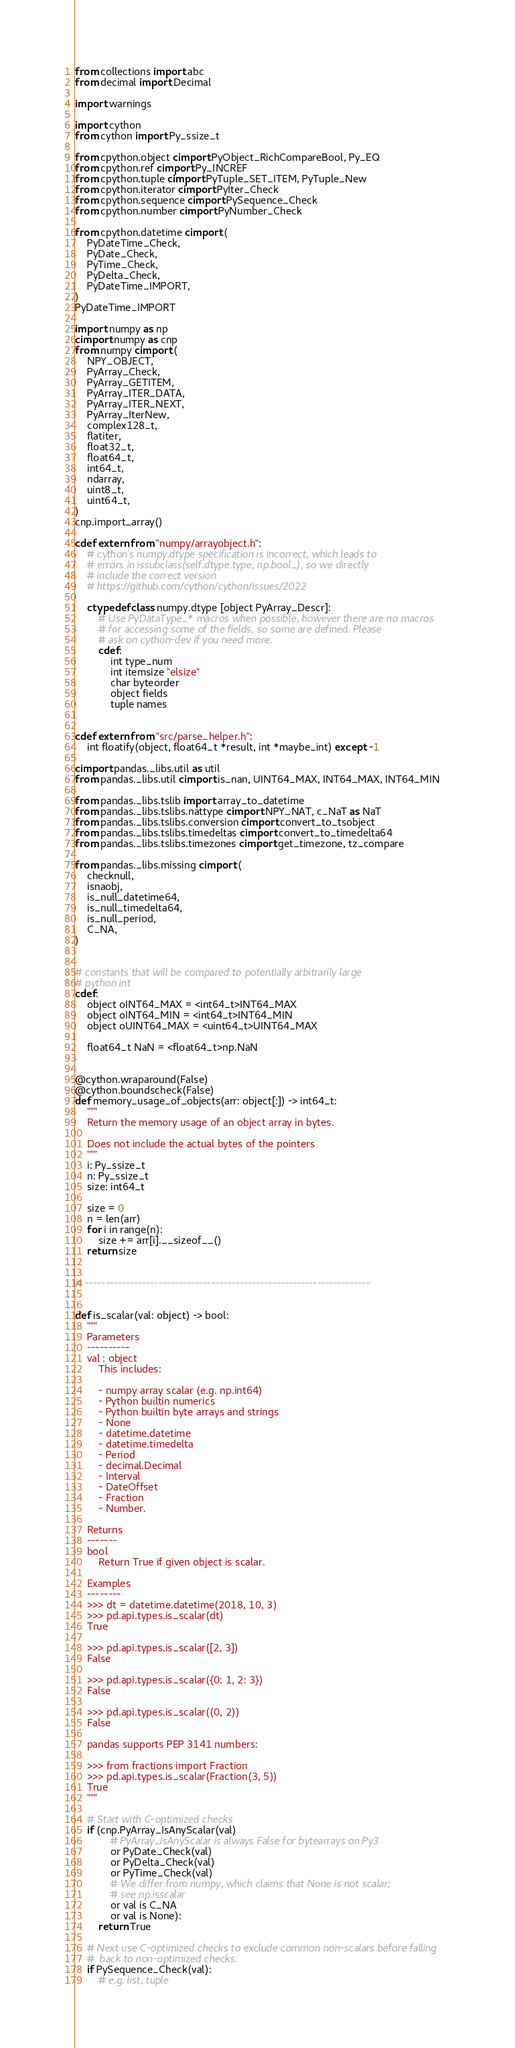<code> <loc_0><loc_0><loc_500><loc_500><_Cython_>from collections import abc
from decimal import Decimal

import warnings

import cython
from cython import Py_ssize_t

from cpython.object cimport PyObject_RichCompareBool, Py_EQ
from cpython.ref cimport Py_INCREF
from cpython.tuple cimport PyTuple_SET_ITEM, PyTuple_New
from cpython.iterator cimport PyIter_Check
from cpython.sequence cimport PySequence_Check
from cpython.number cimport PyNumber_Check

from cpython.datetime cimport (
    PyDateTime_Check,
    PyDate_Check,
    PyTime_Check,
    PyDelta_Check,
    PyDateTime_IMPORT,
)
PyDateTime_IMPORT

import numpy as np
cimport numpy as cnp
from numpy cimport (
    NPY_OBJECT,
    PyArray_Check,
    PyArray_GETITEM,
    PyArray_ITER_DATA,
    PyArray_ITER_NEXT,
    PyArray_IterNew,
    complex128_t,
    flatiter,
    float32_t,
    float64_t,
    int64_t,
    ndarray,
    uint8_t,
    uint64_t,
)
cnp.import_array()

cdef extern from "numpy/arrayobject.h":
    # cython's numpy.dtype specification is incorrect, which leads to
    # errors in issubclass(self.dtype.type, np.bool_), so we directly
    # include the correct version
    # https://github.com/cython/cython/issues/2022

    ctypedef class numpy.dtype [object PyArray_Descr]:
        # Use PyDataType_* macros when possible, however there are no macros
        # for accessing some of the fields, so some are defined. Please
        # ask on cython-dev if you need more.
        cdef:
            int type_num
            int itemsize "elsize"
            char byteorder
            object fields
            tuple names


cdef extern from "src/parse_helper.h":
    int floatify(object, float64_t *result, int *maybe_int) except -1

cimport pandas._libs.util as util
from pandas._libs.util cimport is_nan, UINT64_MAX, INT64_MAX, INT64_MIN

from pandas._libs.tslib import array_to_datetime
from pandas._libs.tslibs.nattype cimport NPY_NAT, c_NaT as NaT
from pandas._libs.tslibs.conversion cimport convert_to_tsobject
from pandas._libs.tslibs.timedeltas cimport convert_to_timedelta64
from pandas._libs.tslibs.timezones cimport get_timezone, tz_compare

from pandas._libs.missing cimport (
    checknull,
    isnaobj,
    is_null_datetime64,
    is_null_timedelta64,
    is_null_period,
    C_NA,
)


# constants that will be compared to potentially arbitrarily large
# python int
cdef:
    object oINT64_MAX = <int64_t>INT64_MAX
    object oINT64_MIN = <int64_t>INT64_MIN
    object oUINT64_MAX = <uint64_t>UINT64_MAX

    float64_t NaN = <float64_t>np.NaN


@cython.wraparound(False)
@cython.boundscheck(False)
def memory_usage_of_objects(arr: object[:]) -> int64_t:
    """
    Return the memory usage of an object array in bytes.

    Does not include the actual bytes of the pointers
    """
    i: Py_ssize_t
    n: Py_ssize_t
    size: int64_t

    size = 0
    n = len(arr)
    for i in range(n):
        size += arr[i].__sizeof__()
    return size


# ----------------------------------------------------------------------


def is_scalar(val: object) -> bool:
    """
    Parameters
    ----------
    val : object
        This includes:

        - numpy array scalar (e.g. np.int64)
        - Python builtin numerics
        - Python builtin byte arrays and strings
        - None
        - datetime.datetime
        - datetime.timedelta
        - Period
        - decimal.Decimal
        - Interval
        - DateOffset
        - Fraction
        - Number.

    Returns
    -------
    bool
        Return True if given object is scalar.

    Examples
    --------
    >>> dt = datetime.datetime(2018, 10, 3)
    >>> pd.api.types.is_scalar(dt)
    True

    >>> pd.api.types.is_scalar([2, 3])
    False

    >>> pd.api.types.is_scalar({0: 1, 2: 3})
    False

    >>> pd.api.types.is_scalar((0, 2))
    False

    pandas supports PEP 3141 numbers:

    >>> from fractions import Fraction
    >>> pd.api.types.is_scalar(Fraction(3, 5))
    True
    """

    # Start with C-optimized checks
    if (cnp.PyArray_IsAnyScalar(val)
            # PyArray_IsAnyScalar is always False for bytearrays on Py3
            or PyDate_Check(val)
            or PyDelta_Check(val)
            or PyTime_Check(val)
            # We differ from numpy, which claims that None is not scalar;
            # see np.isscalar
            or val is C_NA
            or val is None):
        return True

    # Next use C-optimized checks to exclude common non-scalars before falling
    #  back to non-optimized checks.
    if PySequence_Check(val):
        # e.g. list, tuple</code> 